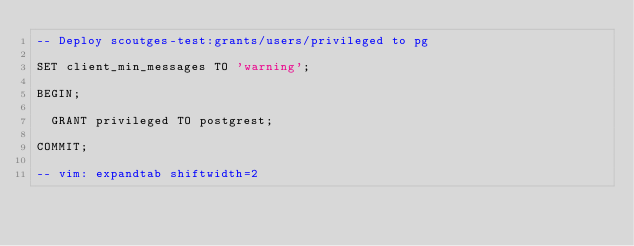Convert code to text. <code><loc_0><loc_0><loc_500><loc_500><_SQL_>-- Deploy scoutges-test:grants/users/privileged to pg

SET client_min_messages TO 'warning';

BEGIN;

  GRANT privileged TO postgrest;

COMMIT;

-- vim: expandtab shiftwidth=2
</code> 